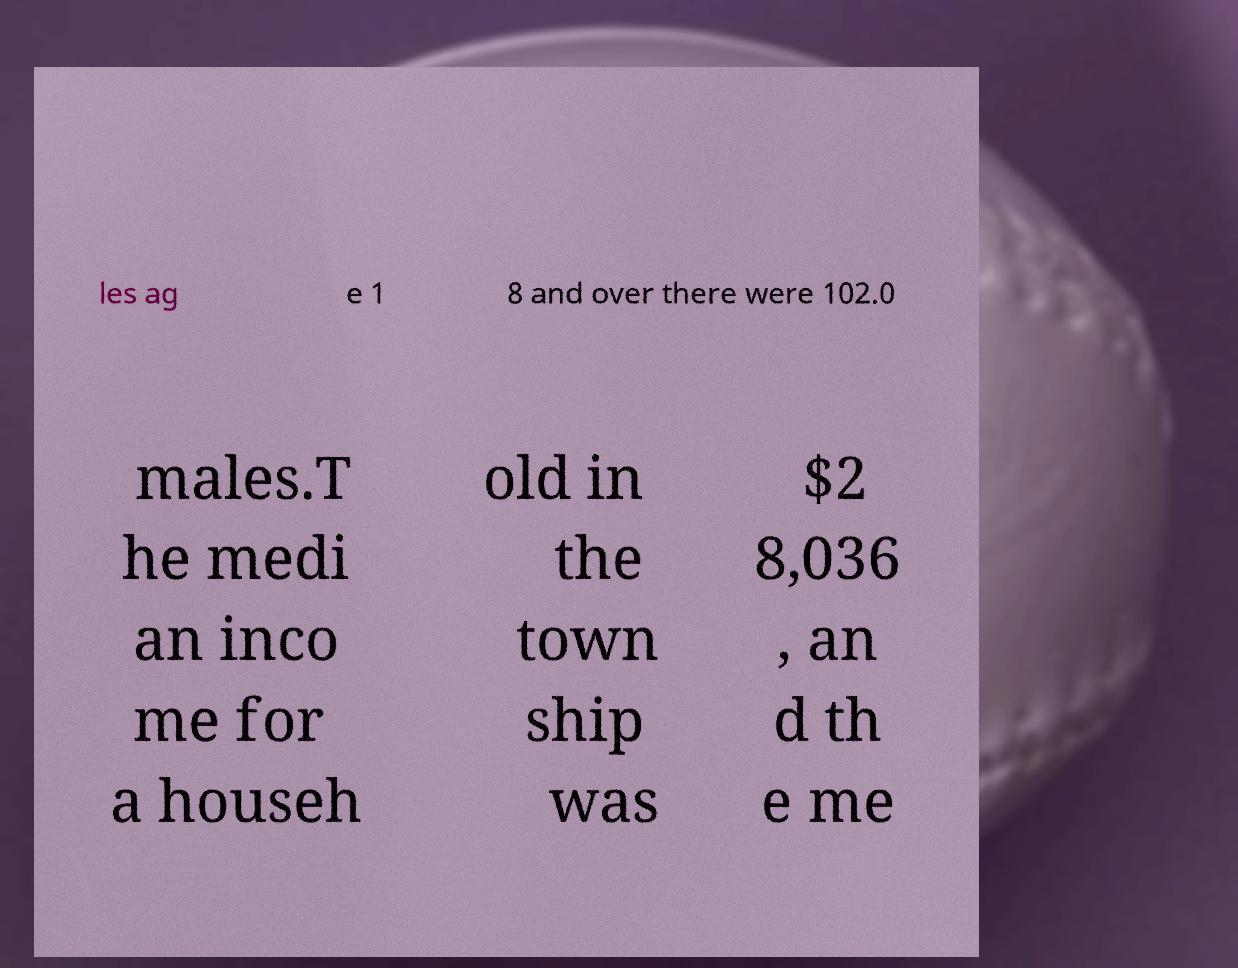Please identify and transcribe the text found in this image. les ag e 1 8 and over there were 102.0 males.T he medi an inco me for a househ old in the town ship was $2 8,036 , an d th e me 